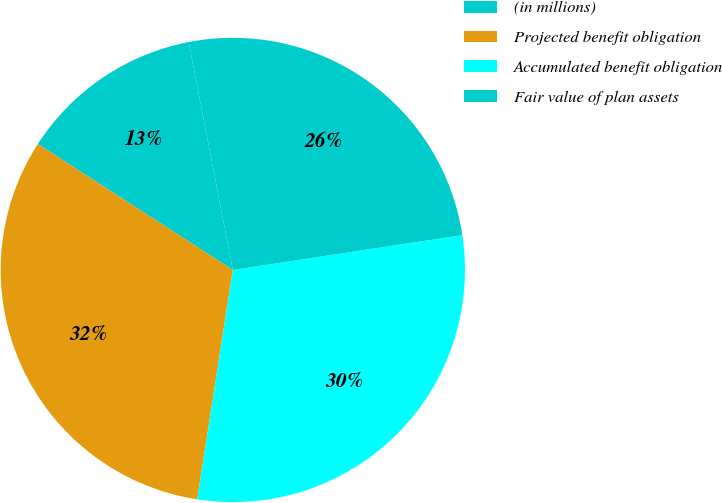Convert chart. <chart><loc_0><loc_0><loc_500><loc_500><pie_chart><fcel>(in millions)<fcel>Projected benefit obligation<fcel>Accumulated benefit obligation<fcel>Fair value of plan assets<nl><fcel>12.83%<fcel>31.68%<fcel>29.85%<fcel>25.65%<nl></chart> 